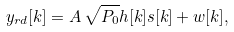Convert formula to latex. <formula><loc_0><loc_0><loc_500><loc_500>y _ { r d } [ k ] = A \, \sqrt { P _ { 0 } } h [ k ] s [ k ] + w [ k ] ,</formula> 